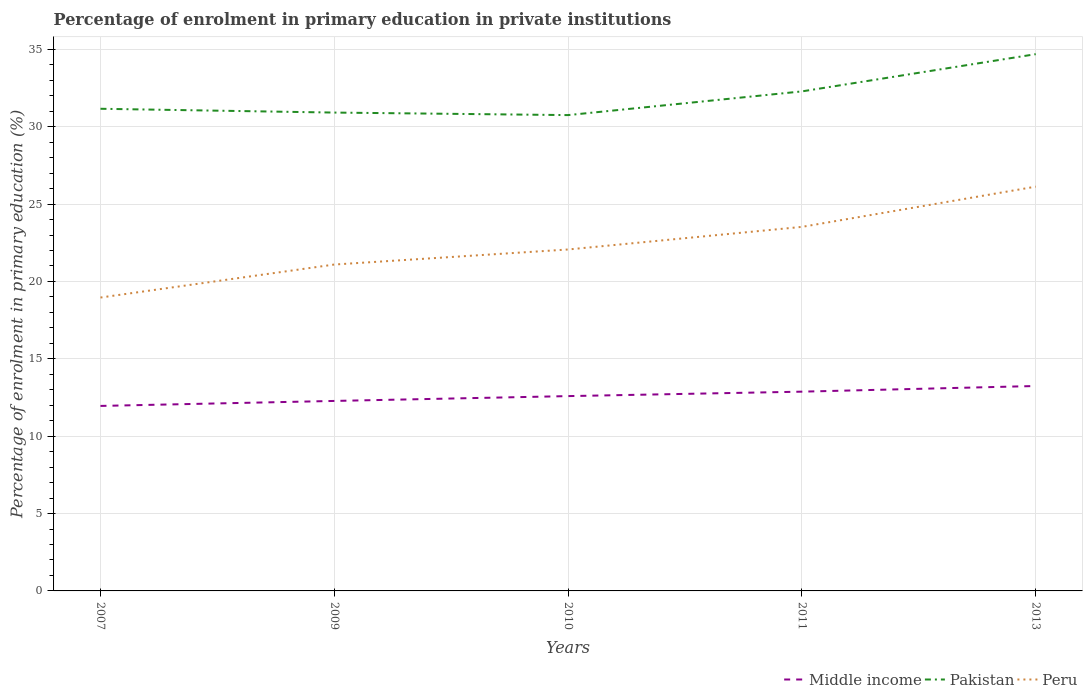How many different coloured lines are there?
Provide a succinct answer. 3. Is the number of lines equal to the number of legend labels?
Offer a terse response. Yes. Across all years, what is the maximum percentage of enrolment in primary education in Peru?
Keep it short and to the point. 18.96. In which year was the percentage of enrolment in primary education in Middle income maximum?
Offer a very short reply. 2007. What is the total percentage of enrolment in primary education in Pakistan in the graph?
Provide a short and direct response. -3.77. What is the difference between the highest and the second highest percentage of enrolment in primary education in Pakistan?
Provide a succinct answer. 3.94. How many years are there in the graph?
Your answer should be very brief. 5. What is the difference between two consecutive major ticks on the Y-axis?
Your response must be concise. 5. Are the values on the major ticks of Y-axis written in scientific E-notation?
Ensure brevity in your answer.  No. Does the graph contain any zero values?
Give a very brief answer. No. Where does the legend appear in the graph?
Your answer should be compact. Bottom right. How many legend labels are there?
Provide a succinct answer. 3. What is the title of the graph?
Keep it short and to the point. Percentage of enrolment in primary education in private institutions. What is the label or title of the X-axis?
Offer a very short reply. Years. What is the label or title of the Y-axis?
Keep it short and to the point. Percentage of enrolment in primary education (%). What is the Percentage of enrolment in primary education (%) in Middle income in 2007?
Your answer should be compact. 11.96. What is the Percentage of enrolment in primary education (%) of Pakistan in 2007?
Your answer should be very brief. 31.16. What is the Percentage of enrolment in primary education (%) of Peru in 2007?
Offer a very short reply. 18.96. What is the Percentage of enrolment in primary education (%) of Middle income in 2009?
Provide a short and direct response. 12.28. What is the Percentage of enrolment in primary education (%) of Pakistan in 2009?
Provide a short and direct response. 30.91. What is the Percentage of enrolment in primary education (%) of Peru in 2009?
Provide a succinct answer. 21.09. What is the Percentage of enrolment in primary education (%) of Middle income in 2010?
Provide a short and direct response. 12.59. What is the Percentage of enrolment in primary education (%) of Pakistan in 2010?
Ensure brevity in your answer.  30.75. What is the Percentage of enrolment in primary education (%) of Peru in 2010?
Ensure brevity in your answer.  22.07. What is the Percentage of enrolment in primary education (%) of Middle income in 2011?
Your answer should be compact. 12.88. What is the Percentage of enrolment in primary education (%) in Pakistan in 2011?
Offer a very short reply. 32.28. What is the Percentage of enrolment in primary education (%) of Peru in 2011?
Give a very brief answer. 23.53. What is the Percentage of enrolment in primary education (%) of Middle income in 2013?
Offer a very short reply. 13.24. What is the Percentage of enrolment in primary education (%) in Pakistan in 2013?
Make the answer very short. 34.69. What is the Percentage of enrolment in primary education (%) of Peru in 2013?
Your answer should be compact. 26.13. Across all years, what is the maximum Percentage of enrolment in primary education (%) in Middle income?
Provide a short and direct response. 13.24. Across all years, what is the maximum Percentage of enrolment in primary education (%) of Pakistan?
Keep it short and to the point. 34.69. Across all years, what is the maximum Percentage of enrolment in primary education (%) in Peru?
Your answer should be very brief. 26.13. Across all years, what is the minimum Percentage of enrolment in primary education (%) in Middle income?
Your answer should be compact. 11.96. Across all years, what is the minimum Percentage of enrolment in primary education (%) of Pakistan?
Make the answer very short. 30.75. Across all years, what is the minimum Percentage of enrolment in primary education (%) in Peru?
Offer a very short reply. 18.96. What is the total Percentage of enrolment in primary education (%) in Middle income in the graph?
Your answer should be compact. 62.94. What is the total Percentage of enrolment in primary education (%) of Pakistan in the graph?
Offer a very short reply. 159.79. What is the total Percentage of enrolment in primary education (%) in Peru in the graph?
Keep it short and to the point. 111.77. What is the difference between the Percentage of enrolment in primary education (%) of Middle income in 2007 and that in 2009?
Provide a succinct answer. -0.32. What is the difference between the Percentage of enrolment in primary education (%) of Pakistan in 2007 and that in 2009?
Offer a very short reply. 0.25. What is the difference between the Percentage of enrolment in primary education (%) in Peru in 2007 and that in 2009?
Your answer should be compact. -2.13. What is the difference between the Percentage of enrolment in primary education (%) in Middle income in 2007 and that in 2010?
Make the answer very short. -0.63. What is the difference between the Percentage of enrolment in primary education (%) in Pakistan in 2007 and that in 2010?
Keep it short and to the point. 0.41. What is the difference between the Percentage of enrolment in primary education (%) in Peru in 2007 and that in 2010?
Your response must be concise. -3.11. What is the difference between the Percentage of enrolment in primary education (%) of Middle income in 2007 and that in 2011?
Make the answer very short. -0.92. What is the difference between the Percentage of enrolment in primary education (%) of Pakistan in 2007 and that in 2011?
Provide a succinct answer. -1.12. What is the difference between the Percentage of enrolment in primary education (%) of Peru in 2007 and that in 2011?
Your answer should be very brief. -4.57. What is the difference between the Percentage of enrolment in primary education (%) of Middle income in 2007 and that in 2013?
Your response must be concise. -1.29. What is the difference between the Percentage of enrolment in primary education (%) of Pakistan in 2007 and that in 2013?
Ensure brevity in your answer.  -3.53. What is the difference between the Percentage of enrolment in primary education (%) of Peru in 2007 and that in 2013?
Keep it short and to the point. -7.17. What is the difference between the Percentage of enrolment in primary education (%) in Middle income in 2009 and that in 2010?
Your answer should be very brief. -0.31. What is the difference between the Percentage of enrolment in primary education (%) in Pakistan in 2009 and that in 2010?
Offer a very short reply. 0.16. What is the difference between the Percentage of enrolment in primary education (%) in Peru in 2009 and that in 2010?
Keep it short and to the point. -0.97. What is the difference between the Percentage of enrolment in primary education (%) of Middle income in 2009 and that in 2011?
Provide a succinct answer. -0.6. What is the difference between the Percentage of enrolment in primary education (%) of Pakistan in 2009 and that in 2011?
Provide a succinct answer. -1.37. What is the difference between the Percentage of enrolment in primary education (%) of Peru in 2009 and that in 2011?
Give a very brief answer. -2.43. What is the difference between the Percentage of enrolment in primary education (%) in Middle income in 2009 and that in 2013?
Keep it short and to the point. -0.97. What is the difference between the Percentage of enrolment in primary education (%) of Pakistan in 2009 and that in 2013?
Your answer should be very brief. -3.77. What is the difference between the Percentage of enrolment in primary education (%) in Peru in 2009 and that in 2013?
Offer a very short reply. -5.03. What is the difference between the Percentage of enrolment in primary education (%) of Middle income in 2010 and that in 2011?
Offer a terse response. -0.29. What is the difference between the Percentage of enrolment in primary education (%) of Pakistan in 2010 and that in 2011?
Provide a succinct answer. -1.53. What is the difference between the Percentage of enrolment in primary education (%) in Peru in 2010 and that in 2011?
Offer a very short reply. -1.46. What is the difference between the Percentage of enrolment in primary education (%) of Middle income in 2010 and that in 2013?
Your answer should be very brief. -0.65. What is the difference between the Percentage of enrolment in primary education (%) in Pakistan in 2010 and that in 2013?
Ensure brevity in your answer.  -3.94. What is the difference between the Percentage of enrolment in primary education (%) in Peru in 2010 and that in 2013?
Offer a very short reply. -4.06. What is the difference between the Percentage of enrolment in primary education (%) of Middle income in 2011 and that in 2013?
Keep it short and to the point. -0.37. What is the difference between the Percentage of enrolment in primary education (%) of Pakistan in 2011 and that in 2013?
Your response must be concise. -2.41. What is the difference between the Percentage of enrolment in primary education (%) of Peru in 2011 and that in 2013?
Your answer should be very brief. -2.6. What is the difference between the Percentage of enrolment in primary education (%) in Middle income in 2007 and the Percentage of enrolment in primary education (%) in Pakistan in 2009?
Your answer should be very brief. -18.96. What is the difference between the Percentage of enrolment in primary education (%) of Middle income in 2007 and the Percentage of enrolment in primary education (%) of Peru in 2009?
Ensure brevity in your answer.  -9.14. What is the difference between the Percentage of enrolment in primary education (%) in Pakistan in 2007 and the Percentage of enrolment in primary education (%) in Peru in 2009?
Offer a very short reply. 10.07. What is the difference between the Percentage of enrolment in primary education (%) in Middle income in 2007 and the Percentage of enrolment in primary education (%) in Pakistan in 2010?
Your response must be concise. -18.79. What is the difference between the Percentage of enrolment in primary education (%) of Middle income in 2007 and the Percentage of enrolment in primary education (%) of Peru in 2010?
Provide a short and direct response. -10.11. What is the difference between the Percentage of enrolment in primary education (%) of Pakistan in 2007 and the Percentage of enrolment in primary education (%) of Peru in 2010?
Offer a very short reply. 9.09. What is the difference between the Percentage of enrolment in primary education (%) in Middle income in 2007 and the Percentage of enrolment in primary education (%) in Pakistan in 2011?
Give a very brief answer. -20.33. What is the difference between the Percentage of enrolment in primary education (%) in Middle income in 2007 and the Percentage of enrolment in primary education (%) in Peru in 2011?
Keep it short and to the point. -11.57. What is the difference between the Percentage of enrolment in primary education (%) in Pakistan in 2007 and the Percentage of enrolment in primary education (%) in Peru in 2011?
Offer a terse response. 7.63. What is the difference between the Percentage of enrolment in primary education (%) of Middle income in 2007 and the Percentage of enrolment in primary education (%) of Pakistan in 2013?
Give a very brief answer. -22.73. What is the difference between the Percentage of enrolment in primary education (%) of Middle income in 2007 and the Percentage of enrolment in primary education (%) of Peru in 2013?
Your answer should be very brief. -14.17. What is the difference between the Percentage of enrolment in primary education (%) in Pakistan in 2007 and the Percentage of enrolment in primary education (%) in Peru in 2013?
Offer a very short reply. 5.03. What is the difference between the Percentage of enrolment in primary education (%) of Middle income in 2009 and the Percentage of enrolment in primary education (%) of Pakistan in 2010?
Offer a very short reply. -18.47. What is the difference between the Percentage of enrolment in primary education (%) in Middle income in 2009 and the Percentage of enrolment in primary education (%) in Peru in 2010?
Give a very brief answer. -9.79. What is the difference between the Percentage of enrolment in primary education (%) in Pakistan in 2009 and the Percentage of enrolment in primary education (%) in Peru in 2010?
Ensure brevity in your answer.  8.85. What is the difference between the Percentage of enrolment in primary education (%) of Middle income in 2009 and the Percentage of enrolment in primary education (%) of Pakistan in 2011?
Your answer should be very brief. -20. What is the difference between the Percentage of enrolment in primary education (%) in Middle income in 2009 and the Percentage of enrolment in primary education (%) in Peru in 2011?
Keep it short and to the point. -11.25. What is the difference between the Percentage of enrolment in primary education (%) of Pakistan in 2009 and the Percentage of enrolment in primary education (%) of Peru in 2011?
Give a very brief answer. 7.39. What is the difference between the Percentage of enrolment in primary education (%) in Middle income in 2009 and the Percentage of enrolment in primary education (%) in Pakistan in 2013?
Offer a very short reply. -22.41. What is the difference between the Percentage of enrolment in primary education (%) of Middle income in 2009 and the Percentage of enrolment in primary education (%) of Peru in 2013?
Provide a succinct answer. -13.85. What is the difference between the Percentage of enrolment in primary education (%) in Pakistan in 2009 and the Percentage of enrolment in primary education (%) in Peru in 2013?
Provide a short and direct response. 4.79. What is the difference between the Percentage of enrolment in primary education (%) in Middle income in 2010 and the Percentage of enrolment in primary education (%) in Pakistan in 2011?
Give a very brief answer. -19.69. What is the difference between the Percentage of enrolment in primary education (%) in Middle income in 2010 and the Percentage of enrolment in primary education (%) in Peru in 2011?
Ensure brevity in your answer.  -10.94. What is the difference between the Percentage of enrolment in primary education (%) in Pakistan in 2010 and the Percentage of enrolment in primary education (%) in Peru in 2011?
Ensure brevity in your answer.  7.22. What is the difference between the Percentage of enrolment in primary education (%) in Middle income in 2010 and the Percentage of enrolment in primary education (%) in Pakistan in 2013?
Ensure brevity in your answer.  -22.1. What is the difference between the Percentage of enrolment in primary education (%) in Middle income in 2010 and the Percentage of enrolment in primary education (%) in Peru in 2013?
Provide a short and direct response. -13.54. What is the difference between the Percentage of enrolment in primary education (%) of Pakistan in 2010 and the Percentage of enrolment in primary education (%) of Peru in 2013?
Offer a very short reply. 4.62. What is the difference between the Percentage of enrolment in primary education (%) in Middle income in 2011 and the Percentage of enrolment in primary education (%) in Pakistan in 2013?
Your response must be concise. -21.81. What is the difference between the Percentage of enrolment in primary education (%) of Middle income in 2011 and the Percentage of enrolment in primary education (%) of Peru in 2013?
Your answer should be compact. -13.25. What is the difference between the Percentage of enrolment in primary education (%) of Pakistan in 2011 and the Percentage of enrolment in primary education (%) of Peru in 2013?
Provide a succinct answer. 6.16. What is the average Percentage of enrolment in primary education (%) in Middle income per year?
Provide a short and direct response. 12.59. What is the average Percentage of enrolment in primary education (%) in Pakistan per year?
Your answer should be compact. 31.96. What is the average Percentage of enrolment in primary education (%) in Peru per year?
Your response must be concise. 22.35. In the year 2007, what is the difference between the Percentage of enrolment in primary education (%) of Middle income and Percentage of enrolment in primary education (%) of Pakistan?
Give a very brief answer. -19.2. In the year 2007, what is the difference between the Percentage of enrolment in primary education (%) of Middle income and Percentage of enrolment in primary education (%) of Peru?
Your answer should be very brief. -7. In the year 2007, what is the difference between the Percentage of enrolment in primary education (%) of Pakistan and Percentage of enrolment in primary education (%) of Peru?
Your response must be concise. 12.2. In the year 2009, what is the difference between the Percentage of enrolment in primary education (%) in Middle income and Percentage of enrolment in primary education (%) in Pakistan?
Provide a short and direct response. -18.64. In the year 2009, what is the difference between the Percentage of enrolment in primary education (%) in Middle income and Percentage of enrolment in primary education (%) in Peru?
Your answer should be compact. -8.81. In the year 2009, what is the difference between the Percentage of enrolment in primary education (%) in Pakistan and Percentage of enrolment in primary education (%) in Peru?
Give a very brief answer. 9.82. In the year 2010, what is the difference between the Percentage of enrolment in primary education (%) of Middle income and Percentage of enrolment in primary education (%) of Pakistan?
Make the answer very short. -18.16. In the year 2010, what is the difference between the Percentage of enrolment in primary education (%) in Middle income and Percentage of enrolment in primary education (%) in Peru?
Provide a short and direct response. -9.48. In the year 2010, what is the difference between the Percentage of enrolment in primary education (%) in Pakistan and Percentage of enrolment in primary education (%) in Peru?
Your answer should be compact. 8.68. In the year 2011, what is the difference between the Percentage of enrolment in primary education (%) of Middle income and Percentage of enrolment in primary education (%) of Pakistan?
Provide a succinct answer. -19.4. In the year 2011, what is the difference between the Percentage of enrolment in primary education (%) in Middle income and Percentage of enrolment in primary education (%) in Peru?
Your response must be concise. -10.65. In the year 2011, what is the difference between the Percentage of enrolment in primary education (%) in Pakistan and Percentage of enrolment in primary education (%) in Peru?
Provide a succinct answer. 8.76. In the year 2013, what is the difference between the Percentage of enrolment in primary education (%) in Middle income and Percentage of enrolment in primary education (%) in Pakistan?
Your response must be concise. -21.44. In the year 2013, what is the difference between the Percentage of enrolment in primary education (%) in Middle income and Percentage of enrolment in primary education (%) in Peru?
Your answer should be very brief. -12.88. In the year 2013, what is the difference between the Percentage of enrolment in primary education (%) of Pakistan and Percentage of enrolment in primary education (%) of Peru?
Ensure brevity in your answer.  8.56. What is the ratio of the Percentage of enrolment in primary education (%) in Middle income in 2007 to that in 2009?
Ensure brevity in your answer.  0.97. What is the ratio of the Percentage of enrolment in primary education (%) in Pakistan in 2007 to that in 2009?
Offer a very short reply. 1.01. What is the ratio of the Percentage of enrolment in primary education (%) in Peru in 2007 to that in 2009?
Offer a very short reply. 0.9. What is the ratio of the Percentage of enrolment in primary education (%) of Middle income in 2007 to that in 2010?
Offer a very short reply. 0.95. What is the ratio of the Percentage of enrolment in primary education (%) of Pakistan in 2007 to that in 2010?
Your answer should be compact. 1.01. What is the ratio of the Percentage of enrolment in primary education (%) of Peru in 2007 to that in 2010?
Give a very brief answer. 0.86. What is the ratio of the Percentage of enrolment in primary education (%) in Middle income in 2007 to that in 2011?
Make the answer very short. 0.93. What is the ratio of the Percentage of enrolment in primary education (%) of Pakistan in 2007 to that in 2011?
Give a very brief answer. 0.97. What is the ratio of the Percentage of enrolment in primary education (%) of Peru in 2007 to that in 2011?
Provide a succinct answer. 0.81. What is the ratio of the Percentage of enrolment in primary education (%) of Middle income in 2007 to that in 2013?
Offer a very short reply. 0.9. What is the ratio of the Percentage of enrolment in primary education (%) of Pakistan in 2007 to that in 2013?
Offer a terse response. 0.9. What is the ratio of the Percentage of enrolment in primary education (%) in Peru in 2007 to that in 2013?
Keep it short and to the point. 0.73. What is the ratio of the Percentage of enrolment in primary education (%) of Middle income in 2009 to that in 2010?
Your answer should be compact. 0.98. What is the ratio of the Percentage of enrolment in primary education (%) of Pakistan in 2009 to that in 2010?
Provide a short and direct response. 1.01. What is the ratio of the Percentage of enrolment in primary education (%) of Peru in 2009 to that in 2010?
Ensure brevity in your answer.  0.96. What is the ratio of the Percentage of enrolment in primary education (%) in Middle income in 2009 to that in 2011?
Provide a short and direct response. 0.95. What is the ratio of the Percentage of enrolment in primary education (%) of Pakistan in 2009 to that in 2011?
Give a very brief answer. 0.96. What is the ratio of the Percentage of enrolment in primary education (%) of Peru in 2009 to that in 2011?
Your answer should be very brief. 0.9. What is the ratio of the Percentage of enrolment in primary education (%) in Middle income in 2009 to that in 2013?
Offer a terse response. 0.93. What is the ratio of the Percentage of enrolment in primary education (%) of Pakistan in 2009 to that in 2013?
Offer a very short reply. 0.89. What is the ratio of the Percentage of enrolment in primary education (%) in Peru in 2009 to that in 2013?
Your answer should be very brief. 0.81. What is the ratio of the Percentage of enrolment in primary education (%) of Middle income in 2010 to that in 2011?
Offer a terse response. 0.98. What is the ratio of the Percentage of enrolment in primary education (%) of Pakistan in 2010 to that in 2011?
Your response must be concise. 0.95. What is the ratio of the Percentage of enrolment in primary education (%) in Peru in 2010 to that in 2011?
Ensure brevity in your answer.  0.94. What is the ratio of the Percentage of enrolment in primary education (%) in Middle income in 2010 to that in 2013?
Your answer should be compact. 0.95. What is the ratio of the Percentage of enrolment in primary education (%) in Pakistan in 2010 to that in 2013?
Keep it short and to the point. 0.89. What is the ratio of the Percentage of enrolment in primary education (%) in Peru in 2010 to that in 2013?
Offer a very short reply. 0.84. What is the ratio of the Percentage of enrolment in primary education (%) of Middle income in 2011 to that in 2013?
Give a very brief answer. 0.97. What is the ratio of the Percentage of enrolment in primary education (%) in Pakistan in 2011 to that in 2013?
Your response must be concise. 0.93. What is the ratio of the Percentage of enrolment in primary education (%) in Peru in 2011 to that in 2013?
Your response must be concise. 0.9. What is the difference between the highest and the second highest Percentage of enrolment in primary education (%) in Middle income?
Your response must be concise. 0.37. What is the difference between the highest and the second highest Percentage of enrolment in primary education (%) in Pakistan?
Provide a short and direct response. 2.41. What is the difference between the highest and the second highest Percentage of enrolment in primary education (%) of Peru?
Give a very brief answer. 2.6. What is the difference between the highest and the lowest Percentage of enrolment in primary education (%) of Middle income?
Keep it short and to the point. 1.29. What is the difference between the highest and the lowest Percentage of enrolment in primary education (%) of Pakistan?
Keep it short and to the point. 3.94. What is the difference between the highest and the lowest Percentage of enrolment in primary education (%) in Peru?
Provide a succinct answer. 7.17. 